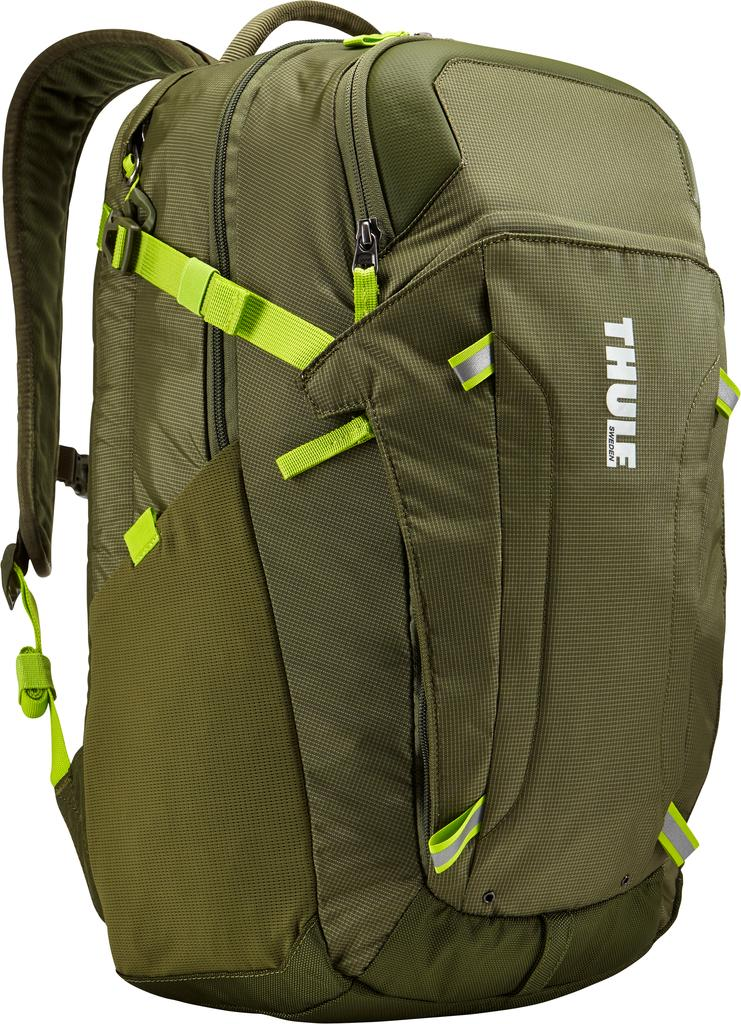What is present in the image? There is a backpack in the image. Can you describe the backpack in more detail? Unfortunately, the image only shows a backpack, and no further details are provided. What type of cheese is being advertised on the sign near the backpack? There is no sign or cheese present in the image; it only features a backpack. 